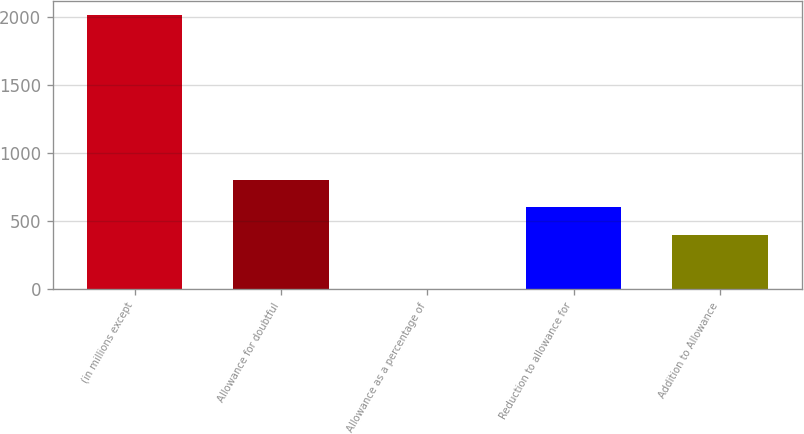Convert chart. <chart><loc_0><loc_0><loc_500><loc_500><bar_chart><fcel>(in millions except<fcel>Allowance for doubtful<fcel>Allowance as a percentage of<fcel>Reduction to allowance for<fcel>Addition to Allowance<nl><fcel>2012<fcel>804.89<fcel>0.13<fcel>603.7<fcel>402.51<nl></chart> 